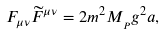Convert formula to latex. <formula><loc_0><loc_0><loc_500><loc_500>F _ { \mu \nu } \widetilde { F } ^ { \mu \nu } = 2 m ^ { 2 } M _ { _ { P } } g ^ { 2 } a ,</formula> 